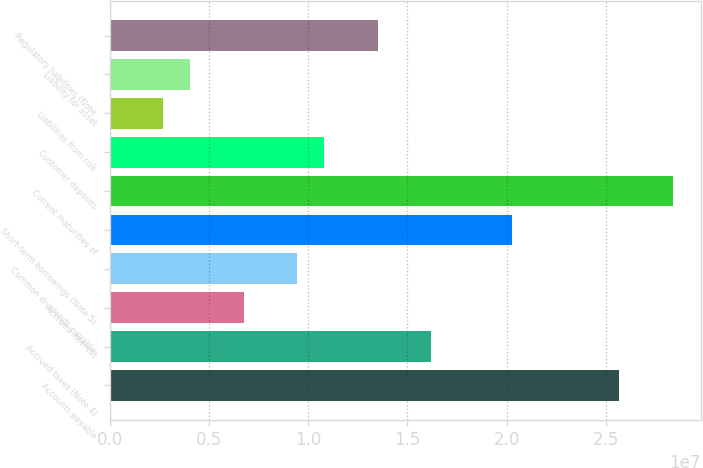<chart> <loc_0><loc_0><loc_500><loc_500><bar_chart><fcel>Accounts payable<fcel>Accrued taxes (Note 4)<fcel>Accrued interest<fcel>Common dividends payable<fcel>Short-term borrowings (Note 5)<fcel>Current maturities of<fcel>Customer deposits<fcel>Liabilities from risk<fcel>Liability for asset<fcel>Regulatory liabilities (Note<nl><fcel>2.56626e+07<fcel>1.62096e+07<fcel>6.7565e+06<fcel>9.45737e+06<fcel>2.02609e+07<fcel>2.83635e+07<fcel>1.08078e+07<fcel>2.70518e+06<fcel>4.05562e+06<fcel>1.35087e+07<nl></chart> 